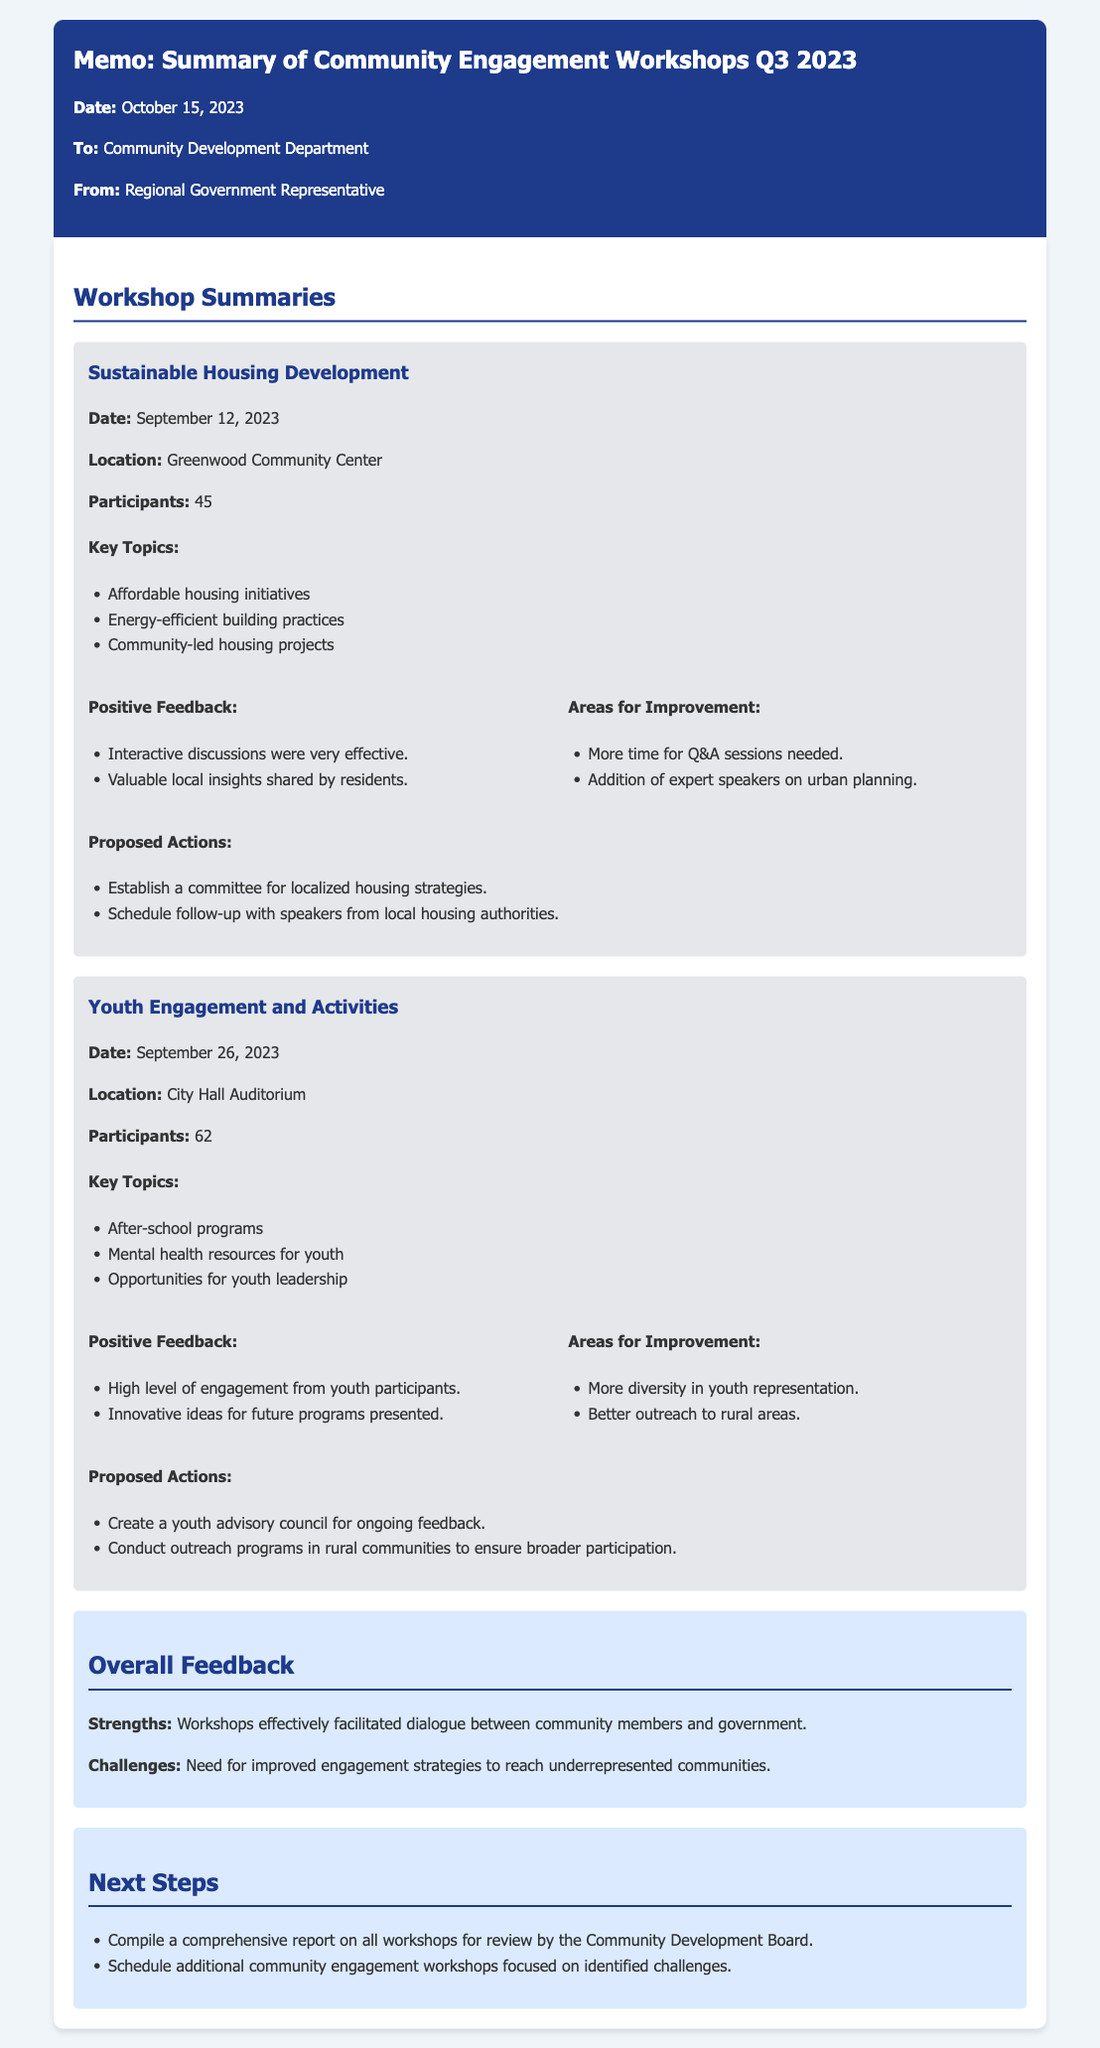What was the date of the Sustainable Housing Development workshop? The specific date is provided in the memo under the workshop summary for Sustainable Housing Development.
Answer: September 12, 2023 How many participants attended the Youth Engagement and Activities workshop? The memo states the participant count for the Youth Engagement and Activities workshop.
Answer: 62 What location hosted the Sustainable Housing Development workshop? The memo lists the location for the workshop.
Answer: Greenwood Community Center What proposed action was suggested for the Youth Engagement and Activities workshop? The proposed actions are outlined in the summary of the workshop.
Answer: Create a youth advisory council for ongoing feedback What was highlighted as a strength of the workshops? The overall feedback section mentions the strengths of the workshops.
Answer: Facilitated dialogue between community members and government What is one area for improvement mentioned in the workshops? The areas for improvement are specified under the feedback sections of each workshop.
Answer: More diversity in youth representation What is one proposed next step following the workshops? The next steps section lists actions to be taken after the workshops.
Answer: Compile a comprehensive report on all workshops for review by the Community Development Board What were the key topics discussed in the Youth Engagement and Activities workshop? The key topics are outlined in the summary of the workshop.
Answer: After-school programs, Mental health resources for youth, Opportunities for youth leadership 